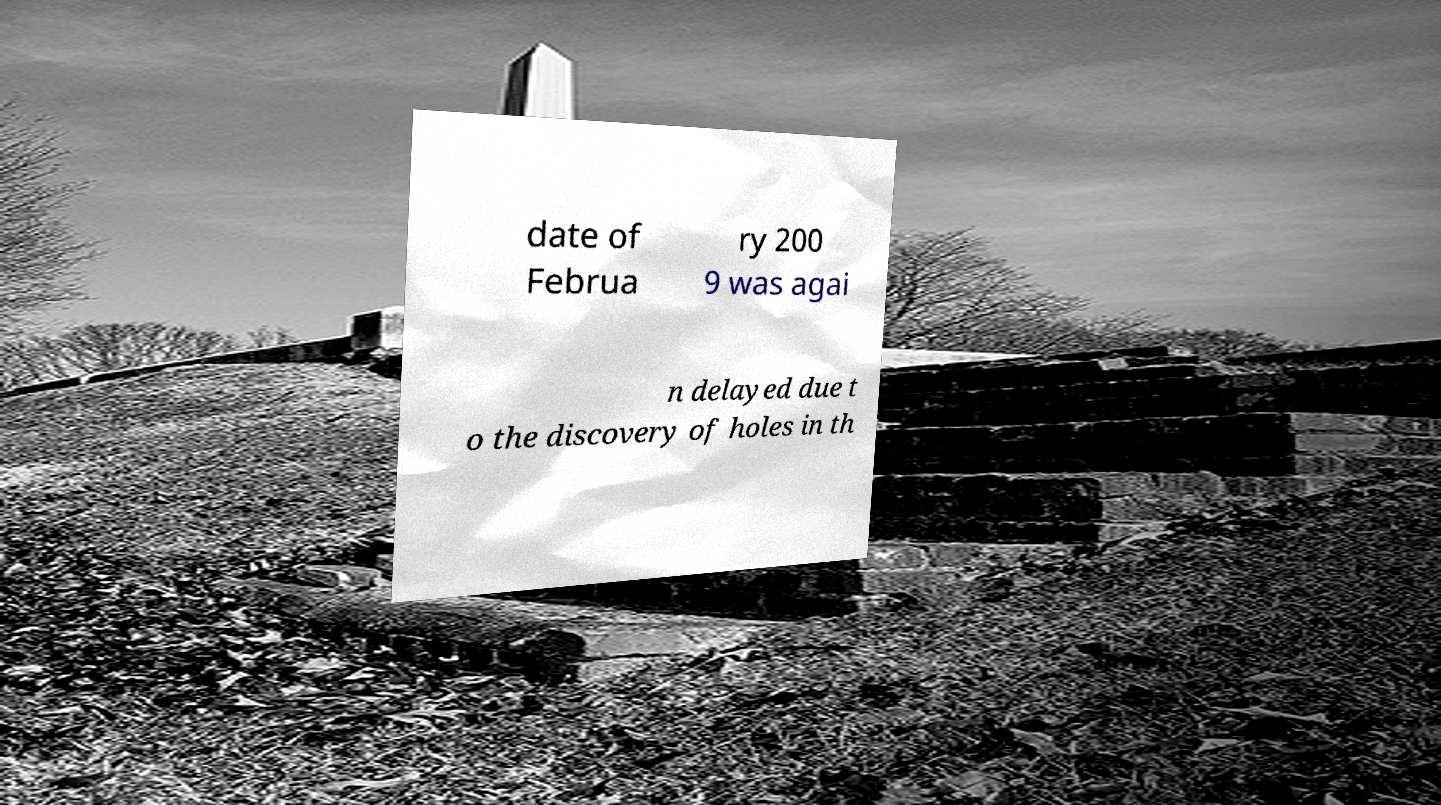For documentation purposes, I need the text within this image transcribed. Could you provide that? date of Februa ry 200 9 was agai n delayed due t o the discovery of holes in th 